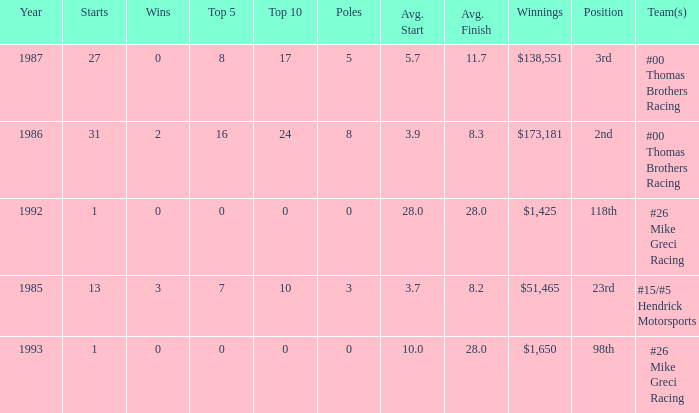How many years did he have an average finish of 11.7? 1.0. 